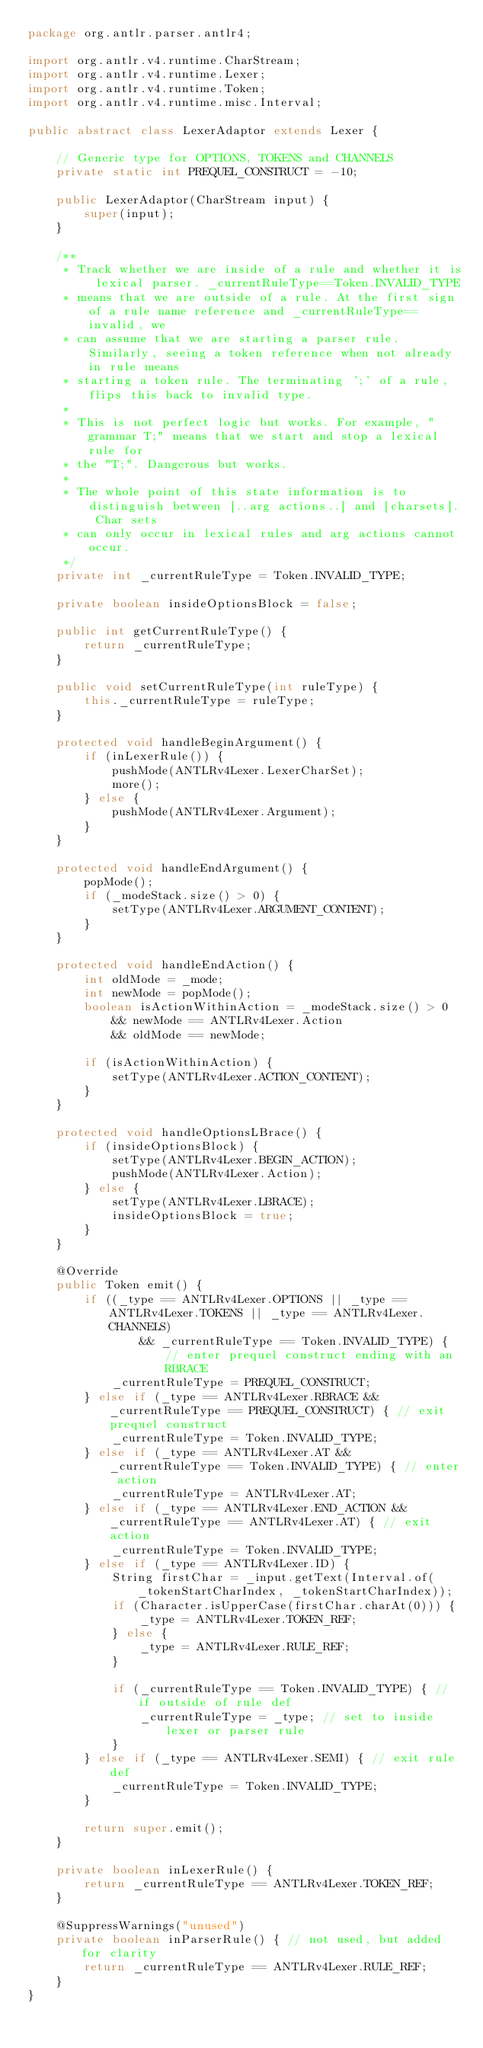<code> <loc_0><loc_0><loc_500><loc_500><_Java_>package org.antlr.parser.antlr4;

import org.antlr.v4.runtime.CharStream;
import org.antlr.v4.runtime.Lexer;
import org.antlr.v4.runtime.Token;
import org.antlr.v4.runtime.misc.Interval;

public abstract class LexerAdaptor extends Lexer {

	// Generic type for OPTIONS, TOKENS and CHANNELS
	private static int PREQUEL_CONSTRUCT = -10;

	public LexerAdaptor(CharStream input) {
		super(input);
	}

	/**
	 * Track whether we are inside of a rule and whether it is lexical parser. _currentRuleType==Token.INVALID_TYPE
	 * means that we are outside of a rule. At the first sign of a rule name reference and _currentRuleType==invalid, we
	 * can assume that we are starting a parser rule. Similarly, seeing a token reference when not already in rule means
	 * starting a token rule. The terminating ';' of a rule, flips this back to invalid type.
	 *
	 * This is not perfect logic but works. For example, "grammar T;" means that we start and stop a lexical rule for
	 * the "T;". Dangerous but works.
	 *
	 * The whole point of this state information is to distinguish between [..arg actions..] and [charsets]. Char sets
	 * can only occur in lexical rules and arg actions cannot occur.
	 */
	private int _currentRuleType = Token.INVALID_TYPE;

	private boolean insideOptionsBlock = false;

	public int getCurrentRuleType() {
		return _currentRuleType;
	}

	public void setCurrentRuleType(int ruleType) {
		this._currentRuleType = ruleType;
	}

	protected void handleBeginArgument() {
		if (inLexerRule()) {
			pushMode(ANTLRv4Lexer.LexerCharSet);
			more();
		} else {
			pushMode(ANTLRv4Lexer.Argument);
		}
	}

	protected void handleEndArgument() {
		popMode();
		if (_modeStack.size() > 0) {
			setType(ANTLRv4Lexer.ARGUMENT_CONTENT);
		}
	}

	protected void handleEndAction() {
	    int oldMode = _mode;
        int newMode = popMode();
        boolean isActionWithinAction = _modeStack.size() > 0
            && newMode == ANTLRv4Lexer.Action
            && oldMode == newMode;

		if (isActionWithinAction) {
			setType(ANTLRv4Lexer.ACTION_CONTENT);
		}
	}

	protected void handleOptionsLBrace() {
		if (insideOptionsBlock) {
			setType(ANTLRv4Lexer.BEGIN_ACTION);
			pushMode(ANTLRv4Lexer.Action);
		} else {
			setType(ANTLRv4Lexer.LBRACE);
			insideOptionsBlock = true;
		}
	}

	@Override
	public Token emit() {
		if ((_type == ANTLRv4Lexer.OPTIONS || _type == ANTLRv4Lexer.TOKENS || _type == ANTLRv4Lexer.CHANNELS)
				&& _currentRuleType == Token.INVALID_TYPE) { // enter prequel construct ending with an RBRACE
			_currentRuleType = PREQUEL_CONSTRUCT;
		} else if (_type == ANTLRv4Lexer.RBRACE && _currentRuleType == PREQUEL_CONSTRUCT) { // exit prequel construct
			_currentRuleType = Token.INVALID_TYPE;
		} else if (_type == ANTLRv4Lexer.AT && _currentRuleType == Token.INVALID_TYPE) { // enter action
			_currentRuleType = ANTLRv4Lexer.AT;
		} else if (_type == ANTLRv4Lexer.END_ACTION && _currentRuleType == ANTLRv4Lexer.AT) { // exit action
			_currentRuleType = Token.INVALID_TYPE;
		} else if (_type == ANTLRv4Lexer.ID) {
			String firstChar = _input.getText(Interval.of(_tokenStartCharIndex, _tokenStartCharIndex));
			if (Character.isUpperCase(firstChar.charAt(0))) {
				_type = ANTLRv4Lexer.TOKEN_REF;
			} else {
				_type = ANTLRv4Lexer.RULE_REF;
			}

			if (_currentRuleType == Token.INVALID_TYPE) { // if outside of rule def
				_currentRuleType = _type; // set to inside lexer or parser rule
			}
		} else if (_type == ANTLRv4Lexer.SEMI) { // exit rule def
			_currentRuleType = Token.INVALID_TYPE;
		}

		return super.emit();
	}

	private boolean inLexerRule() {
		return _currentRuleType == ANTLRv4Lexer.TOKEN_REF;
	}

	@SuppressWarnings("unused")
	private boolean inParserRule() { // not used, but added for clarity
		return _currentRuleType == ANTLRv4Lexer.RULE_REF;
	}
}</code> 